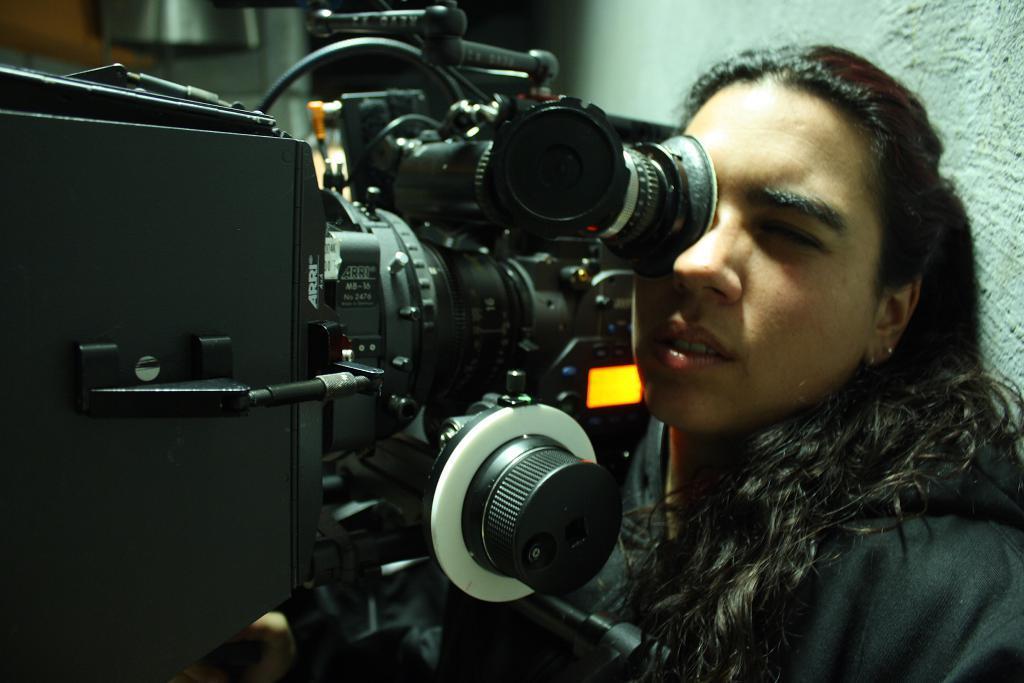Please provide a concise description of this image. In this image I can see a woman wearing black colored dress and I can see a huge camera which is black in color in front of her. In the background I can see the white colored wall. 